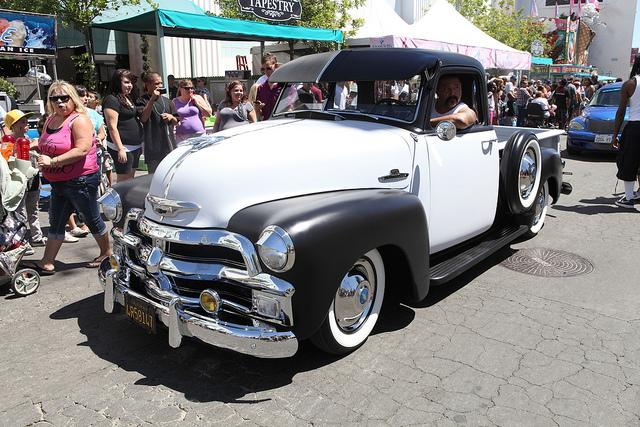Where Tapestry is located? Please explain your reasoning. new york. The picture doesn't give any real ways of showing where it has been taken. 